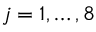Convert formula to latex. <formula><loc_0><loc_0><loc_500><loc_500>j = 1 , \dots , 8</formula> 